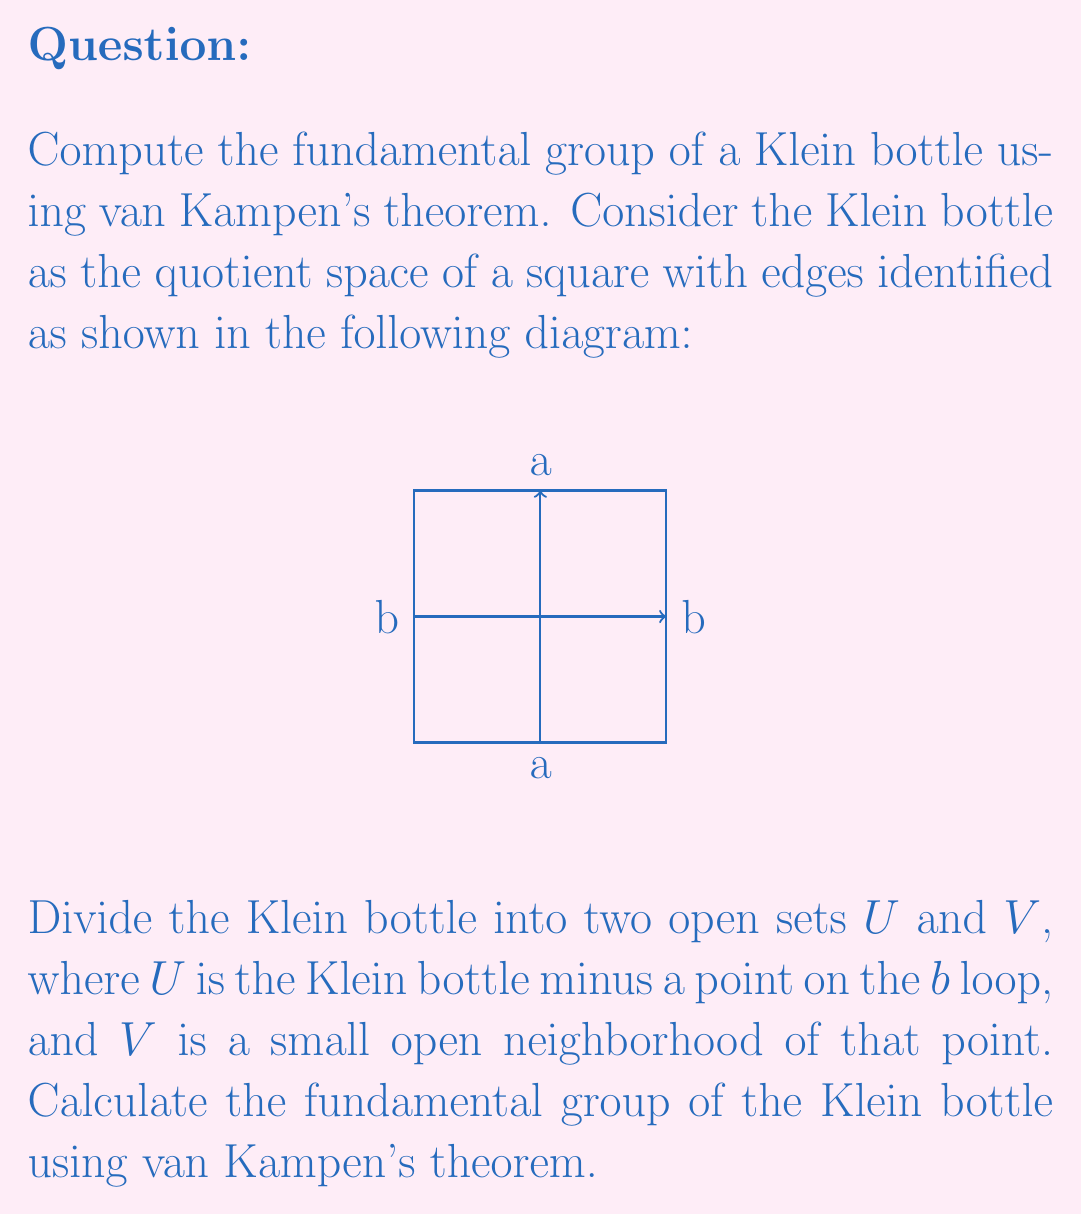Could you help me with this problem? Let's approach this step-by-step:

1) First, we need to understand the topology of $U$ and $V$:
   - $V$ is homeomorphic to an open disc, so $\pi_1(V) \cong \{e\}$ (trivial group)
   - $U$ is homotopy equivalent to a figure-eight, so $\pi_1(U) \cong \mathbb{Z} * \mathbb{Z}$ (free group on two generators)

2) The intersection $U \cap V$ is homotopy equivalent to a circle, so $\pi_1(U \cap V) \cong \mathbb{Z}$

3) Let's denote the generators of $\pi_1(U)$ as $a$ and $b$, corresponding to the loops in the Klein bottle diagram.

4) The inclusion map $i: U \cap V \to U$ sends the generator of $\pi_1(U \cap V)$ to $b^2$ in $\pi_1(U)$. This is because the $b$ loop wraps twice around the removed point.

5) The inclusion map $j: U \cap V \to V$ is trivial, as $V$ is simply connected.

6) By van Kampen's theorem, the fundamental group of the Klein bottle is given by:

   $$\pi_1(\text{Klein bottle}) \cong \pi_1(U) * \pi_1(V) / N$$

   where $N$ is the normal subgroup generated by $i(c)j(c)^{-1}$ for $c \in \pi_1(U \cap V)$

7) In this case, this reduces to:

   $$\pi_1(\text{Klein bottle}) \cong (\mathbb{Z} * \mathbb{Z}) / \langle\langle b^2 \rangle\rangle$$

8) To simplify this further, we need to consider the relation $aba^{-1} = b^{-1}$ in the Klein bottle. This comes from the edge identifications in the original square.

9) Therefore, the fundamental group of the Klein bottle is:

   $$\pi_1(\text{Klein bottle}) \cong \langle a, b \mid aba^{-1}b = 1 \rangle$$

This is the presentation of the fundamental group of the Klein bottle.
Answer: $\langle a, b \mid aba^{-1}b = 1 \rangle$ 